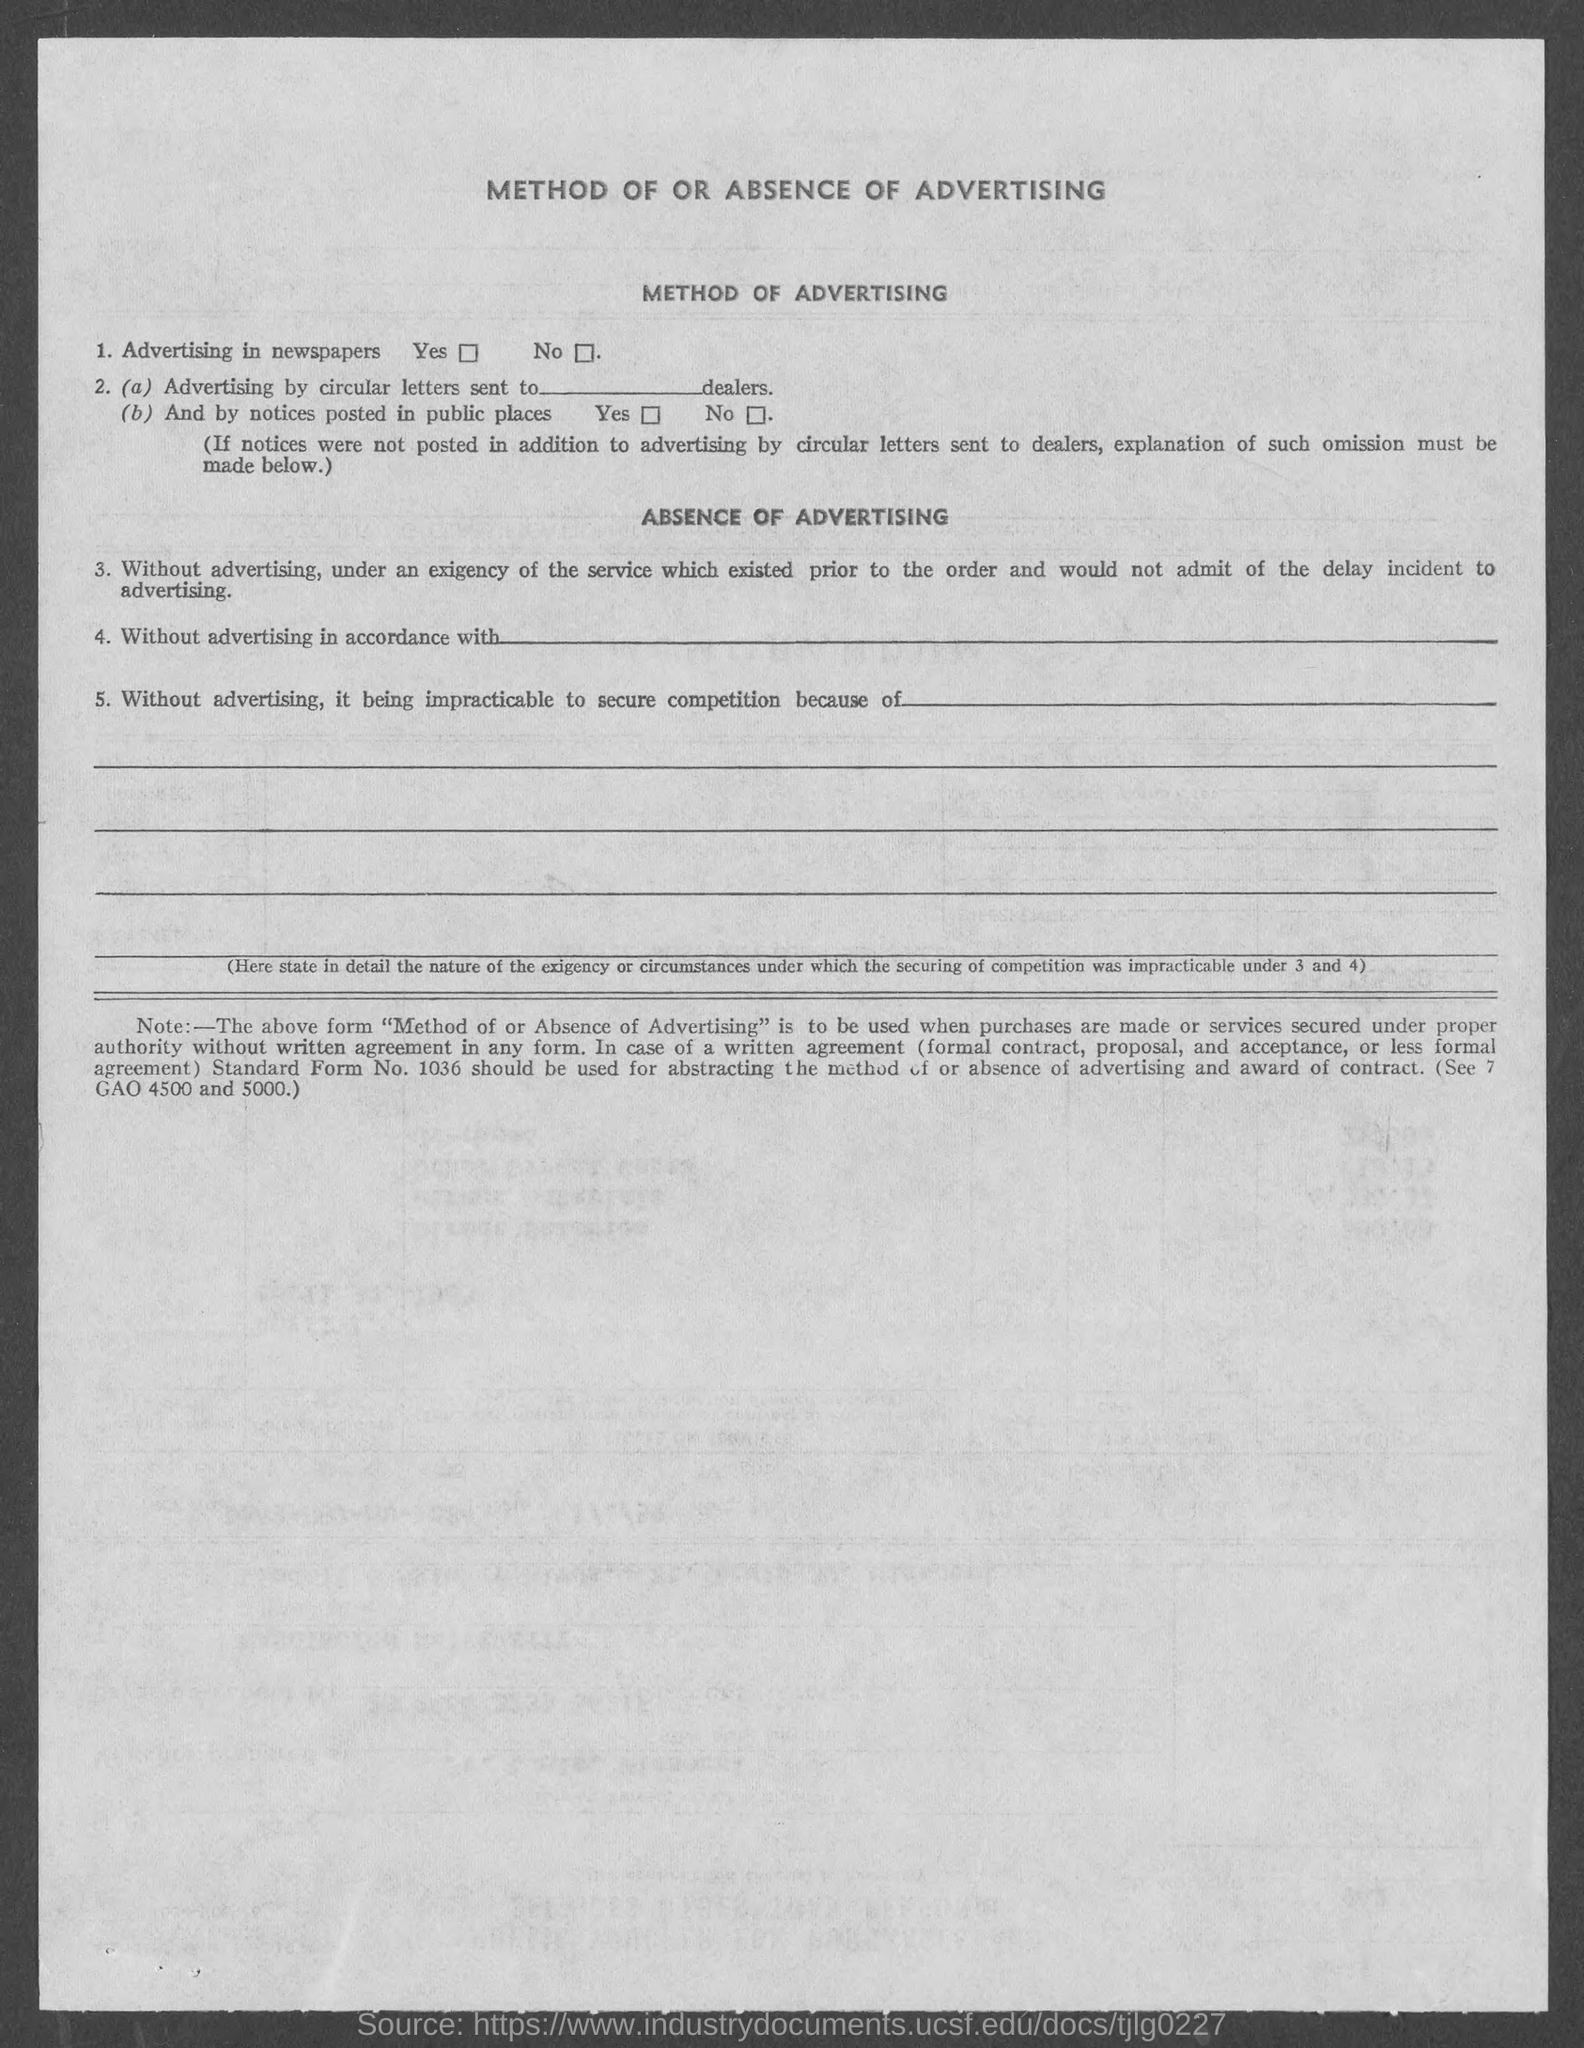Mention a couple of crucial points in this snapshot. The heading at the top of the page is 'METHOD OF OR ABSENCE OF ADVERTISING', which declares the topic of the text that follows. 